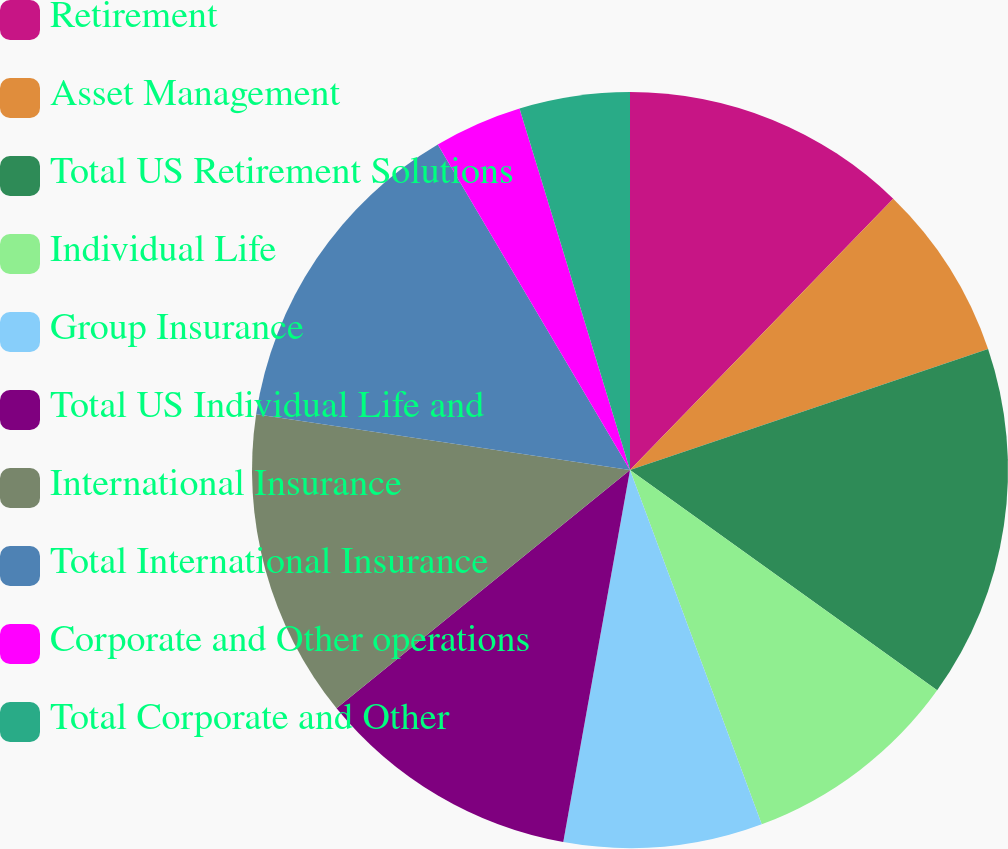<chart> <loc_0><loc_0><loc_500><loc_500><pie_chart><fcel>Retirement<fcel>Asset Management<fcel>Total US Retirement Solutions<fcel>Individual Life<fcel>Group Insurance<fcel>Total US Individual Life and<fcel>International Insurance<fcel>Total International Insurance<fcel>Corporate and Other operations<fcel>Total Corporate and Other<nl><fcel>12.26%<fcel>7.55%<fcel>15.09%<fcel>9.43%<fcel>8.49%<fcel>11.32%<fcel>13.21%<fcel>14.15%<fcel>3.77%<fcel>4.72%<nl></chart> 